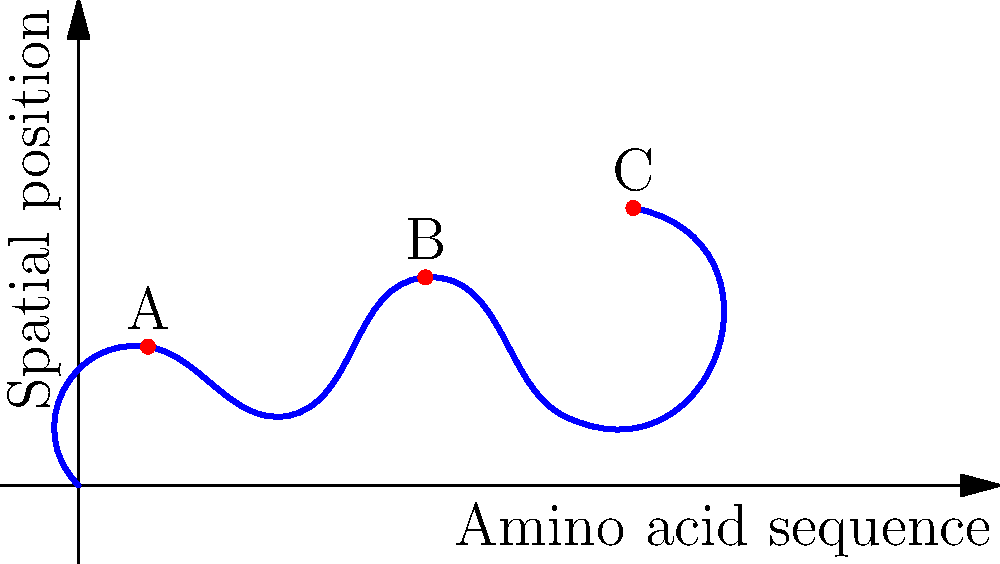The diagram represents a simplified 2D projection of a protein molecule. Three potential binding sites (A, B, and C) are marked. Based on the topology of the protein structure, which binding site is likely to have the highest affinity for a large, hydrophilic ligand, and why? To determine which binding site has the highest affinity for a large, hydrophilic ligand, we need to consider the following steps:

1. Analyze the position of each binding site:
   A: Located at a local maximum
   B: Located at a local maximum
   C: Located at the global maximum

2. Consider the characteristics of a large, hydrophilic ligand:
   - Hydrophilic: Prefers to interact with water and polar environments
   - Large: Requires more space and is less likely to fit into tight pockets

3. Evaluate each binding site:
   A: Local maximum, but not as exposed as B or C
   B: Local maximum, more exposed than A, but less than C
   C: Global maximum, most exposed to the environment

4. Reasoning:
   - A large ligand would have difficulty binding to site A due to steric hindrance
   - Site B is more accessible but still not as exposed as C
   - Site C, being at the global maximum, offers the most exposure and space for a large ligand

5. Consider hydrophilicity:
   - The most exposed site (C) would allow for more interactions with water and the hydrophilic ligand

Therefore, binding site C is likely to have the highest affinity for a large, hydrophilic ligand due to its position at the global maximum, offering the most exposure and space for interaction.
Answer: Binding site C 